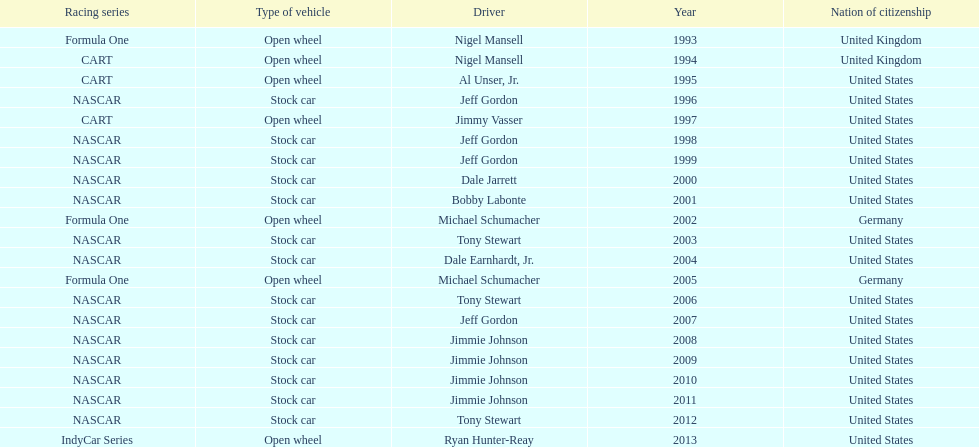Jimmy johnson won how many consecutive espy awards? 4. Would you be able to parse every entry in this table? {'header': ['Racing series', 'Type of vehicle', 'Driver', 'Year', 'Nation of citizenship'], 'rows': [['Formula One', 'Open wheel', 'Nigel Mansell', '1993', 'United Kingdom'], ['CART', 'Open wheel', 'Nigel Mansell', '1994', 'United Kingdom'], ['CART', 'Open wheel', 'Al Unser, Jr.', '1995', 'United States'], ['NASCAR', 'Stock car', 'Jeff Gordon', '1996', 'United States'], ['CART', 'Open wheel', 'Jimmy Vasser', '1997', 'United States'], ['NASCAR', 'Stock car', 'Jeff Gordon', '1998', 'United States'], ['NASCAR', 'Stock car', 'Jeff Gordon', '1999', 'United States'], ['NASCAR', 'Stock car', 'Dale Jarrett', '2000', 'United States'], ['NASCAR', 'Stock car', 'Bobby Labonte', '2001', 'United States'], ['Formula One', 'Open wheel', 'Michael Schumacher', '2002', 'Germany'], ['NASCAR', 'Stock car', 'Tony Stewart', '2003', 'United States'], ['NASCAR', 'Stock car', 'Dale Earnhardt, Jr.', '2004', 'United States'], ['Formula One', 'Open wheel', 'Michael Schumacher', '2005', 'Germany'], ['NASCAR', 'Stock car', 'Tony Stewart', '2006', 'United States'], ['NASCAR', 'Stock car', 'Jeff Gordon', '2007', 'United States'], ['NASCAR', 'Stock car', 'Jimmie Johnson', '2008', 'United States'], ['NASCAR', 'Stock car', 'Jimmie Johnson', '2009', 'United States'], ['NASCAR', 'Stock car', 'Jimmie Johnson', '2010', 'United States'], ['NASCAR', 'Stock car', 'Jimmie Johnson', '2011', 'United States'], ['NASCAR', 'Stock car', 'Tony Stewart', '2012', 'United States'], ['IndyCar Series', 'Open wheel', 'Ryan Hunter-Reay', '2013', 'United States']]} 